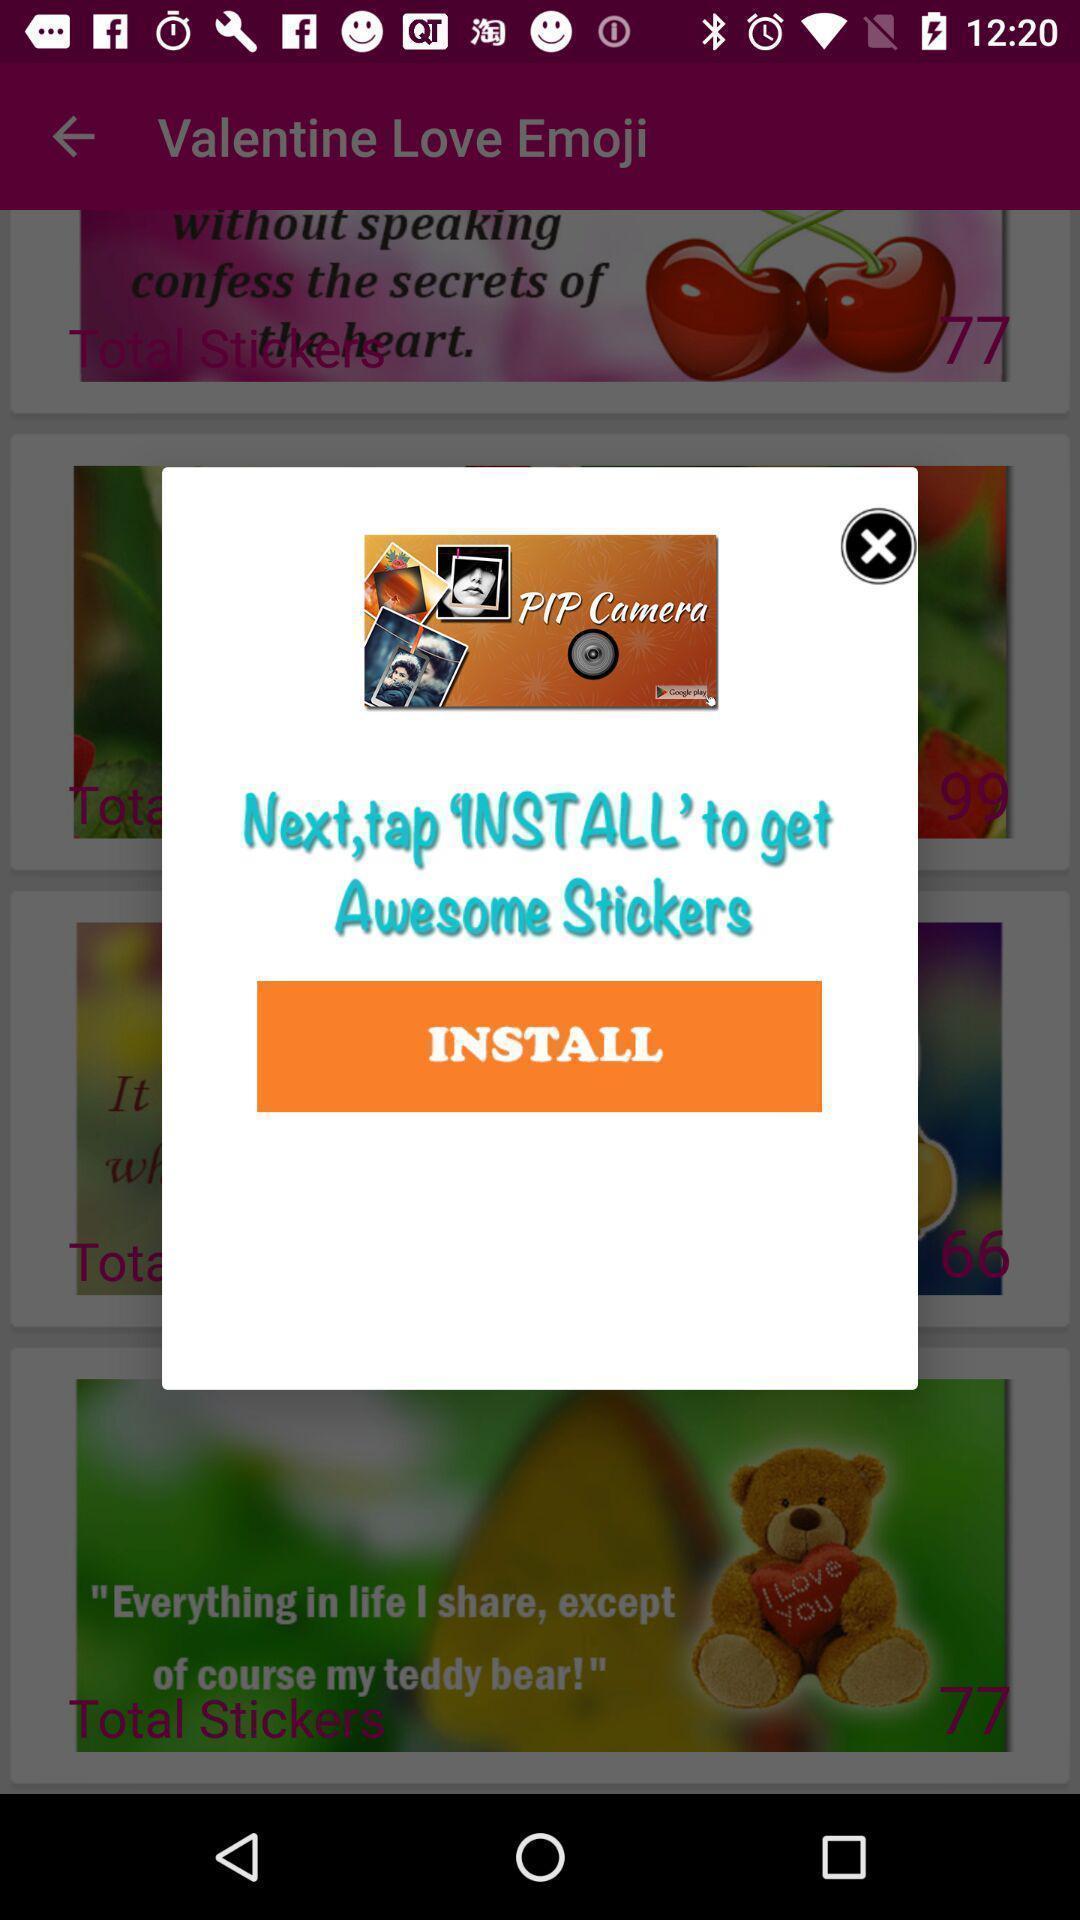What details can you identify in this image? Popup to install. 